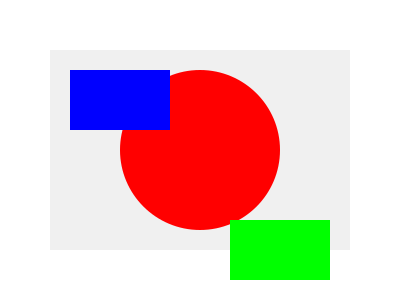In the given graphic, how does the use of color theory contribute to creating a visual hierarchy among the shapes? Explain the principles at work and suggest how this hierarchy could be altered. 1. Color Intensity: The red circle dominates the composition due to its high intensity and warm hue. Red is a naturally attention-grabbing color.

2. Size and Position: The red circle is the largest element and centrally positioned, further emphasizing its importance in the hierarchy.

3. Contrast: The red circle stands out against the light gray background, creating strong contrast.

4. Cool Colors: The blue rectangle is second in the hierarchy. While less intense than red, it's still more prominent than green due to its cooler temperature and higher contrast with the background.

5. Warm vs. Cool: The green rectangle is least noticeable due to its lower contrast with the background and its position at the bottom right.

6. Area Coverage: The amount of space each color occupies also influences hierarchy (red > blue > green).

To alter the hierarchy:
- Increase the saturation of the green rectangle to make it more prominent.
- Reduce the size of the red circle or change its hue to a less intense color.
- Move the blue rectangle to a more central position.
- Adjust the background color to create different contrast relationships.

These changes would shift the visual weight and alter the perceived importance of each element.
Answer: Red circle dominates due to intensity and size; blue rectangle secondary; green least prominent. Alter by changing color intensity, size, or position of elements. 